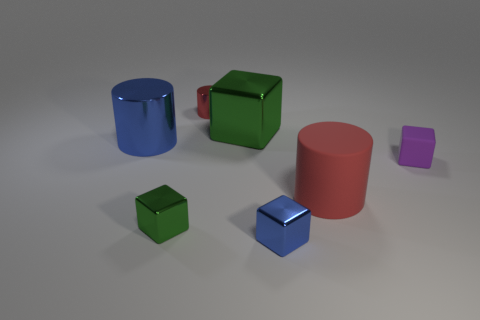What number of things are either metallic objects or blue objects that are in front of the red matte cylinder?
Your answer should be very brief. 5. Are there any tiny matte things that are in front of the tiny metal block that is left of the small red metal object?
Your response must be concise. No. What color is the tiny block on the right side of the big red rubber cylinder?
Provide a succinct answer. Purple. Are there the same number of green metal things on the right side of the red shiny cylinder and large green objects?
Give a very brief answer. Yes. What is the shape of the object that is both in front of the big red object and on the left side of the tiny red metal cylinder?
Offer a terse response. Cube. The small object that is the same shape as the big rubber object is what color?
Make the answer very short. Red. Is there any other thing that has the same color as the matte cylinder?
Provide a short and direct response. Yes. The tiny shiny object that is behind the large object that is in front of the big blue metallic object that is on the left side of the tiny red metallic thing is what shape?
Your answer should be compact. Cylinder. There is a red object that is in front of the large block; does it have the same size as the cube that is on the right side of the big matte object?
Provide a short and direct response. No. How many small red cylinders are made of the same material as the blue cylinder?
Provide a succinct answer. 1. 